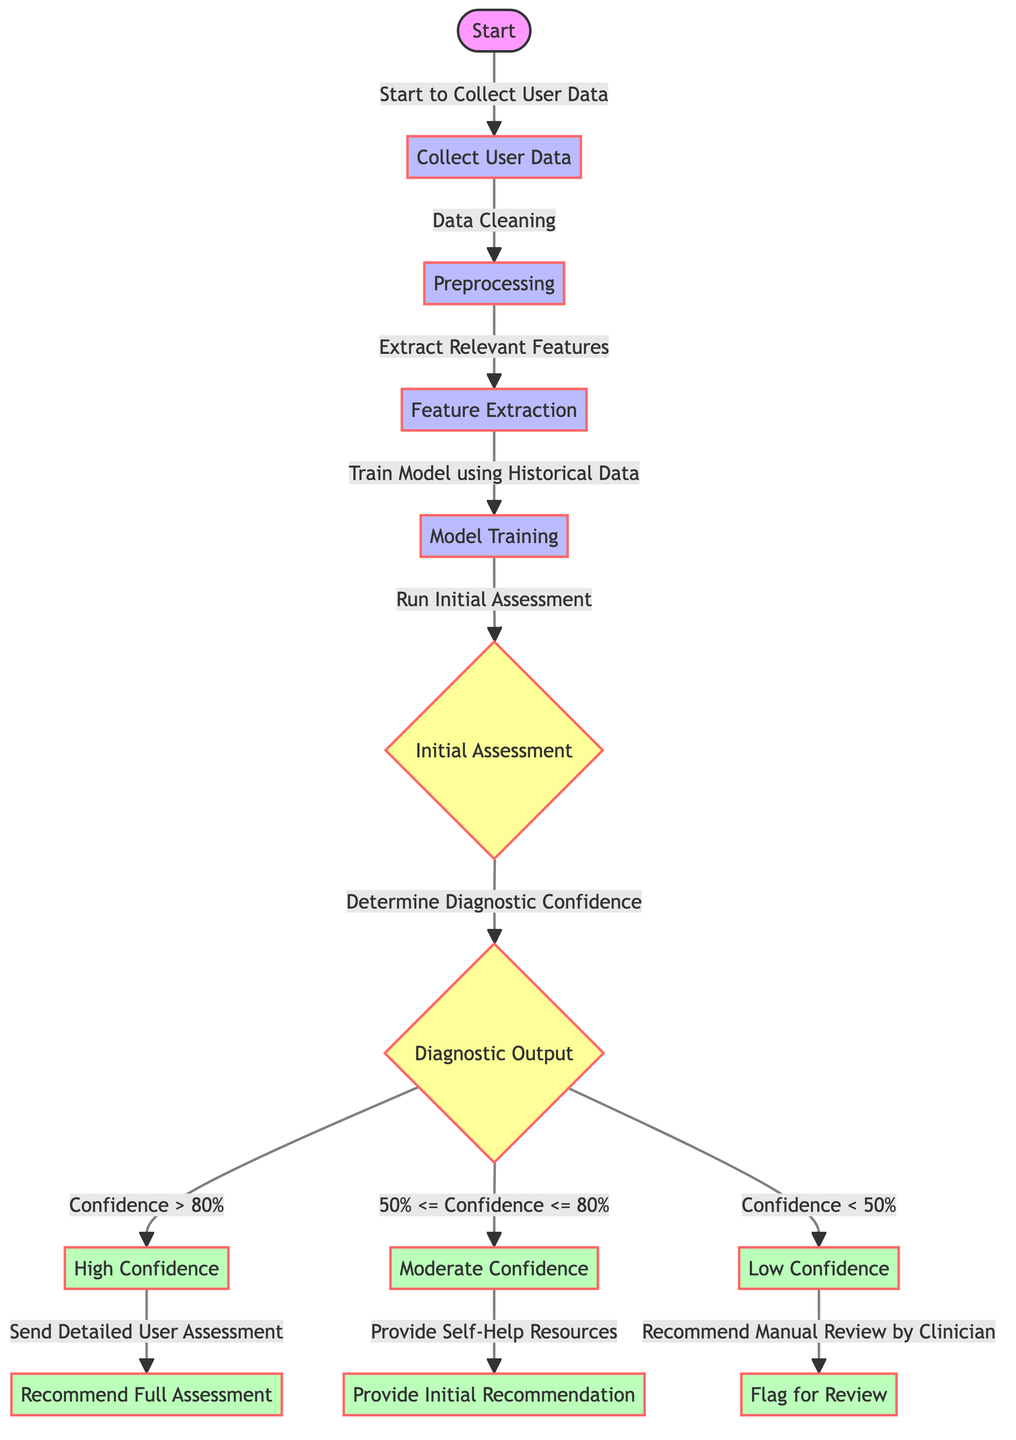What is the first step in the diagram? The first step in the diagram is labeled "Collect User Data," which follows immediately after the start node.
Answer: Collect User Data How many output nodes are present in the diagram? The diagram shows five output nodes, which are "High Confidence," "Moderate Confidence," "Low Confidence," "Recommend Full Assessment," and "Provide Initial Recommendation."
Answer: Five What happens if the confidence level is greater than 80%? If the confidence level is greater than 80%, the diagram indicates that a "Detailed User Assessment" will be sent and subsequently recommends a "Full Assessment."
Answer: Send Detailed User Assessment What type of assessment is conducted after model training? After the model training, the next step involves running the "Initial Assessment," which is a decision node within the flowchart.
Answer: Initial Assessment What does the process recommend if the confidence level is low? If the confidence level is low (less than 50%), the diagram specifies that the process will "Recommend Manual Review by Clinician."
Answer: Recommend Manual Review by Clinician Which node indicates a decision point in the flowchart? The decision points in the flowchart are indicated by the nodes labeled "Initial Assessment" and "Diagnostic Output," both marked with a diamond shape.
Answer: Initial Assessment, Diagnostic Output 